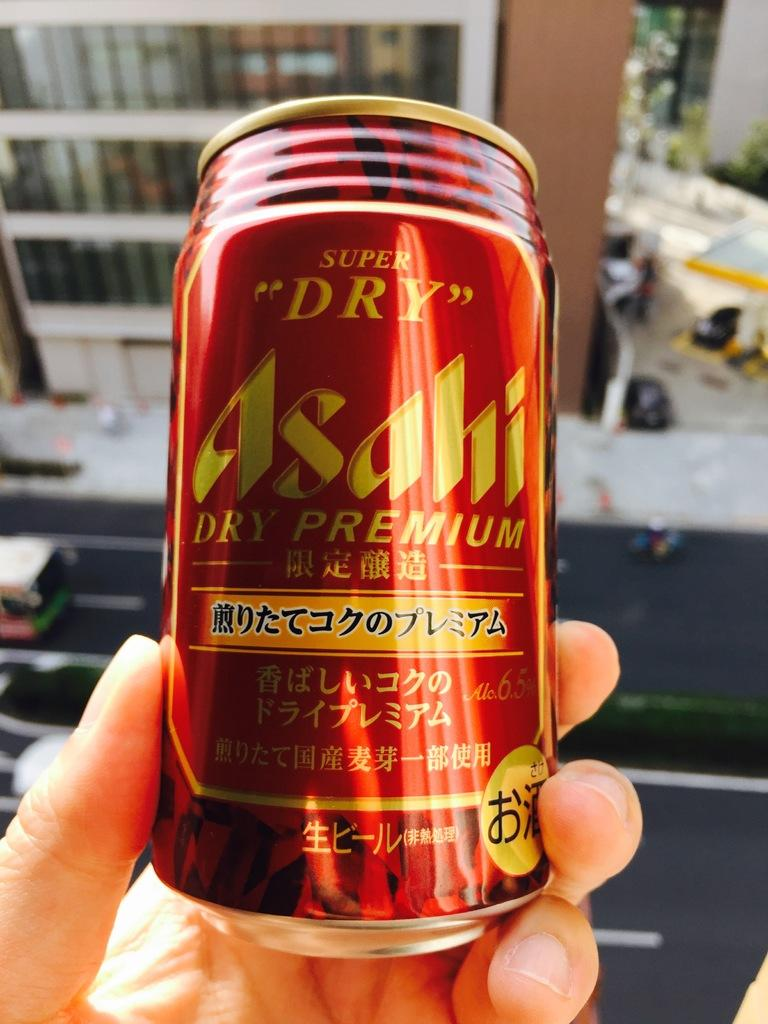<image>
Write a terse but informative summary of the picture. Asahi premium beer is very popular in Asian countries. 